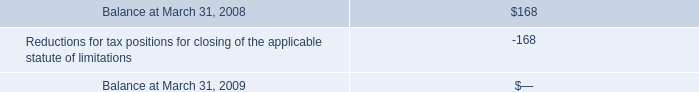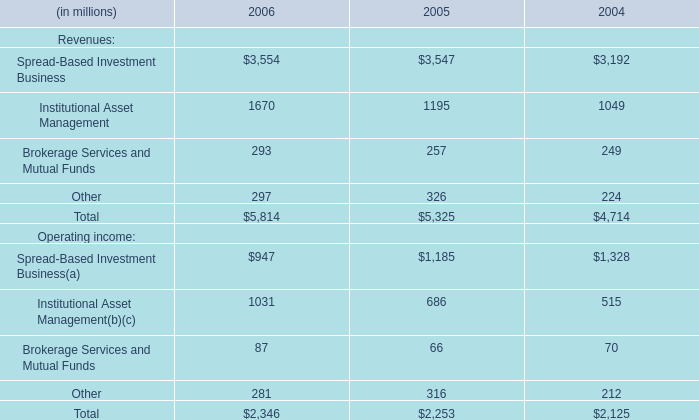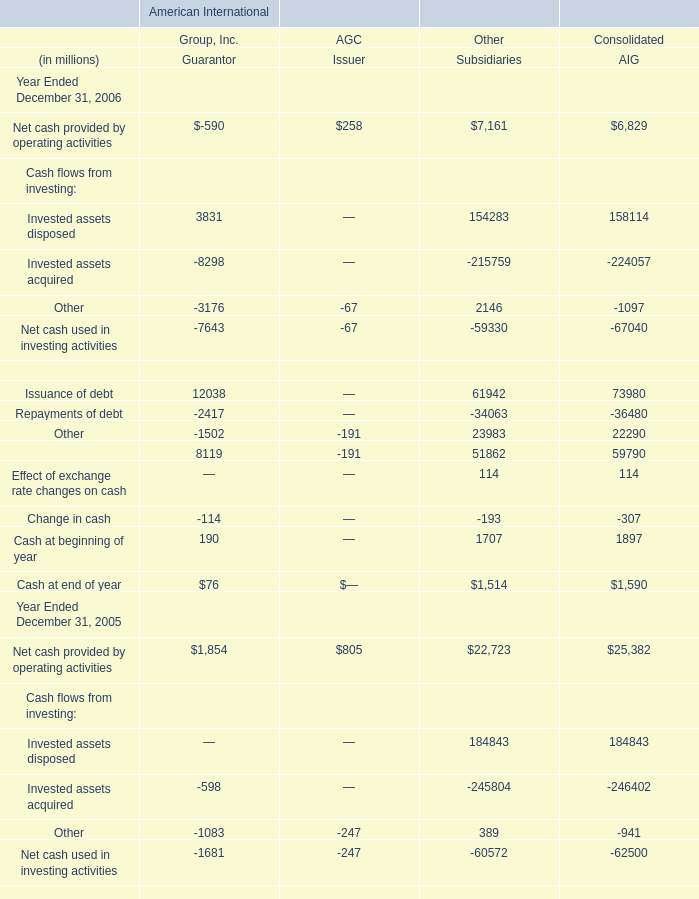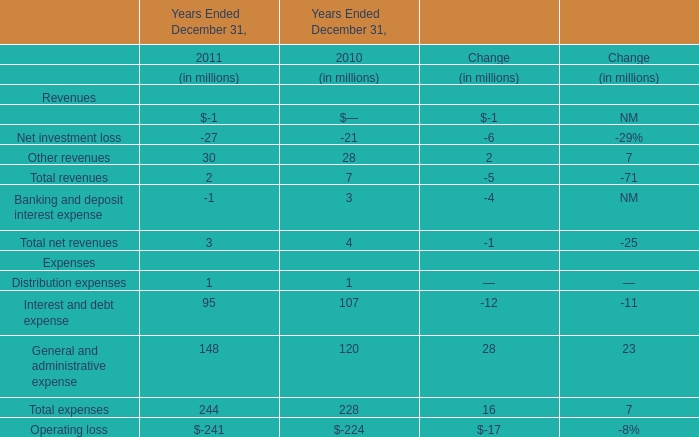What is the ratio of Invested assets disposed of Other Subsidiaries in Table 2 to the Institutional Asset Management in Table 1 in 2005? 
Computations: (184843 / 1195)
Answer: 154.68033. 